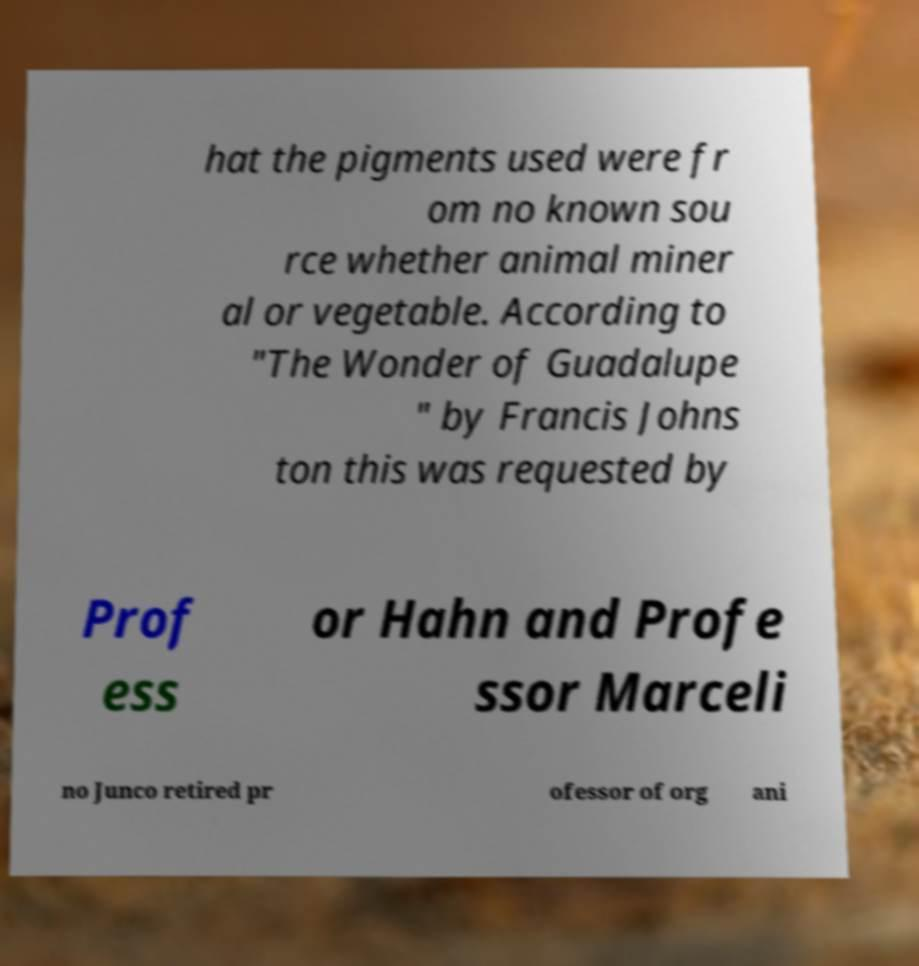There's text embedded in this image that I need extracted. Can you transcribe it verbatim? hat the pigments used were fr om no known sou rce whether animal miner al or vegetable. According to "The Wonder of Guadalupe " by Francis Johns ton this was requested by Prof ess or Hahn and Profe ssor Marceli no Junco retired pr ofessor of org ani 